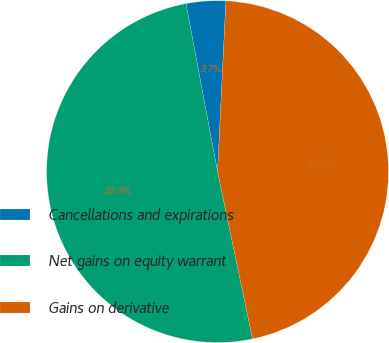<chart> <loc_0><loc_0><loc_500><loc_500><pie_chart><fcel>Cancellations and expirations<fcel>Net gains on equity warrant<fcel>Gains on derivative<nl><fcel>3.74%<fcel>50.32%<fcel>45.93%<nl></chart> 